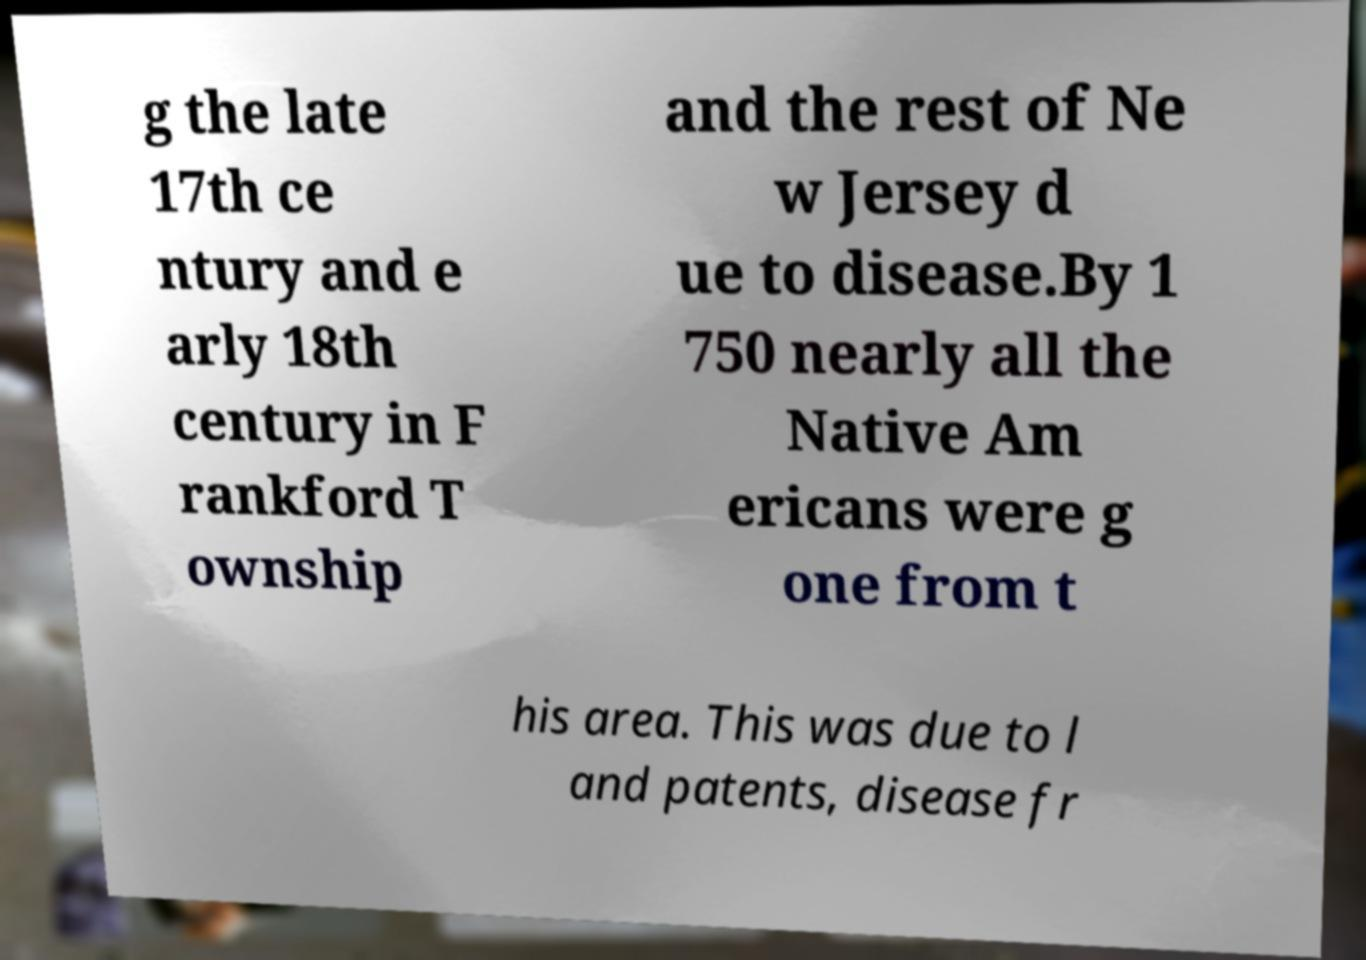Could you extract and type out the text from this image? g the late 17th ce ntury and e arly 18th century in F rankford T ownship and the rest of Ne w Jersey d ue to disease.By 1 750 nearly all the Native Am ericans were g one from t his area. This was due to l and patents, disease fr 